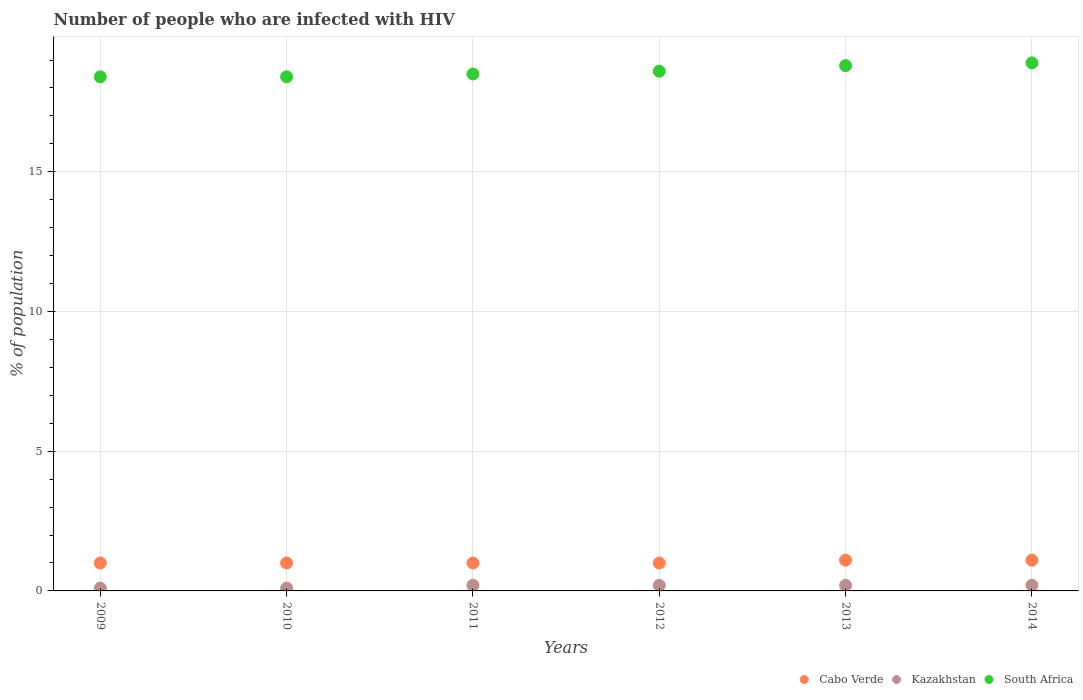How many different coloured dotlines are there?
Your response must be concise. 3. Is the number of dotlines equal to the number of legend labels?
Your response must be concise. Yes. Across all years, what is the maximum percentage of HIV infected population in in Kazakhstan?
Your response must be concise. 0.2. Across all years, what is the minimum percentage of HIV infected population in in South Africa?
Offer a very short reply. 18.4. In which year was the percentage of HIV infected population in in South Africa minimum?
Your response must be concise. 2009. What is the total percentage of HIV infected population in in South Africa in the graph?
Make the answer very short. 111.6. What is the difference between the percentage of HIV infected population in in South Africa in 2010 and that in 2014?
Provide a short and direct response. -0.5. What is the difference between the percentage of HIV infected population in in South Africa in 2013 and the percentage of HIV infected population in in Kazakhstan in 2012?
Provide a short and direct response. 18.6. What is the average percentage of HIV infected population in in South Africa per year?
Your answer should be very brief. 18.6. In the year 2009, what is the difference between the percentage of HIV infected population in in Cabo Verde and percentage of HIV infected population in in South Africa?
Offer a terse response. -17.4. What is the ratio of the percentage of HIV infected population in in South Africa in 2010 to that in 2013?
Provide a short and direct response. 0.98. What is the difference between the highest and the second highest percentage of HIV infected population in in Kazakhstan?
Your response must be concise. 0. What is the difference between the highest and the lowest percentage of HIV infected population in in Cabo Verde?
Make the answer very short. 0.1. In how many years, is the percentage of HIV infected population in in South Africa greater than the average percentage of HIV infected population in in South Africa taken over all years?
Keep it short and to the point. 3. Is the sum of the percentage of HIV infected population in in Kazakhstan in 2009 and 2014 greater than the maximum percentage of HIV infected population in in Cabo Verde across all years?
Offer a terse response. No. Is the percentage of HIV infected population in in South Africa strictly greater than the percentage of HIV infected population in in Kazakhstan over the years?
Provide a short and direct response. Yes. How many dotlines are there?
Offer a very short reply. 3. Are the values on the major ticks of Y-axis written in scientific E-notation?
Provide a short and direct response. No. What is the title of the graph?
Your response must be concise. Number of people who are infected with HIV. Does "Bolivia" appear as one of the legend labels in the graph?
Your answer should be very brief. No. What is the label or title of the Y-axis?
Offer a terse response. % of population. What is the % of population in Kazakhstan in 2009?
Ensure brevity in your answer.  0.1. What is the % of population of South Africa in 2009?
Keep it short and to the point. 18.4. What is the % of population in Cabo Verde in 2010?
Your answer should be compact. 1. What is the % of population in South Africa in 2010?
Ensure brevity in your answer.  18.4. What is the % of population of Cabo Verde in 2011?
Your answer should be compact. 1. What is the % of population in Kazakhstan in 2011?
Offer a very short reply. 0.2. What is the % of population of South Africa in 2011?
Offer a terse response. 18.5. What is the % of population of South Africa in 2012?
Provide a short and direct response. 18.6. What is the % of population of Cabo Verde in 2013?
Provide a succinct answer. 1.1. What is the % of population in South Africa in 2013?
Your response must be concise. 18.8. What is the % of population of South Africa in 2014?
Your answer should be compact. 18.9. Across all years, what is the maximum % of population of Cabo Verde?
Keep it short and to the point. 1.1. Across all years, what is the maximum % of population of Kazakhstan?
Make the answer very short. 0.2. Across all years, what is the minimum % of population of Cabo Verde?
Your response must be concise. 1. Across all years, what is the minimum % of population in Kazakhstan?
Give a very brief answer. 0.1. What is the total % of population of South Africa in the graph?
Your answer should be compact. 111.6. What is the difference between the % of population of Cabo Verde in 2009 and that in 2011?
Ensure brevity in your answer.  0. What is the difference between the % of population in Kazakhstan in 2009 and that in 2012?
Your answer should be compact. -0.1. What is the difference between the % of population in South Africa in 2009 and that in 2012?
Ensure brevity in your answer.  -0.2. What is the difference between the % of population in Kazakhstan in 2009 and that in 2013?
Your answer should be compact. -0.1. What is the difference between the % of population of Cabo Verde in 2009 and that in 2014?
Give a very brief answer. -0.1. What is the difference between the % of population in Kazakhstan in 2009 and that in 2014?
Provide a succinct answer. -0.1. What is the difference between the % of population in Kazakhstan in 2010 and that in 2011?
Your answer should be compact. -0.1. What is the difference between the % of population in South Africa in 2010 and that in 2012?
Provide a short and direct response. -0.2. What is the difference between the % of population of Kazakhstan in 2010 and that in 2013?
Give a very brief answer. -0.1. What is the difference between the % of population in South Africa in 2010 and that in 2013?
Your answer should be very brief. -0.4. What is the difference between the % of population of Cabo Verde in 2010 and that in 2014?
Give a very brief answer. -0.1. What is the difference between the % of population in Kazakhstan in 2010 and that in 2014?
Offer a very short reply. -0.1. What is the difference between the % of population in South Africa in 2010 and that in 2014?
Give a very brief answer. -0.5. What is the difference between the % of population in Cabo Verde in 2011 and that in 2012?
Make the answer very short. 0. What is the difference between the % of population of Kazakhstan in 2011 and that in 2013?
Your response must be concise. 0. What is the difference between the % of population in South Africa in 2011 and that in 2013?
Ensure brevity in your answer.  -0.3. What is the difference between the % of population of Cabo Verde in 2011 and that in 2014?
Offer a very short reply. -0.1. What is the difference between the % of population of Kazakhstan in 2011 and that in 2014?
Make the answer very short. 0. What is the difference between the % of population of South Africa in 2011 and that in 2014?
Your response must be concise. -0.4. What is the difference between the % of population of Kazakhstan in 2012 and that in 2013?
Ensure brevity in your answer.  0. What is the difference between the % of population in South Africa in 2012 and that in 2013?
Offer a terse response. -0.2. What is the difference between the % of population of Cabo Verde in 2012 and that in 2014?
Give a very brief answer. -0.1. What is the difference between the % of population in Kazakhstan in 2012 and that in 2014?
Offer a terse response. 0. What is the difference between the % of population of Kazakhstan in 2013 and that in 2014?
Offer a very short reply. 0. What is the difference between the % of population of South Africa in 2013 and that in 2014?
Your answer should be very brief. -0.1. What is the difference between the % of population in Cabo Verde in 2009 and the % of population in Kazakhstan in 2010?
Your answer should be compact. 0.9. What is the difference between the % of population of Cabo Verde in 2009 and the % of population of South Africa in 2010?
Offer a terse response. -17.4. What is the difference between the % of population of Kazakhstan in 2009 and the % of population of South Africa in 2010?
Give a very brief answer. -18.3. What is the difference between the % of population of Cabo Verde in 2009 and the % of population of Kazakhstan in 2011?
Your response must be concise. 0.8. What is the difference between the % of population in Cabo Verde in 2009 and the % of population in South Africa in 2011?
Your response must be concise. -17.5. What is the difference between the % of population in Kazakhstan in 2009 and the % of population in South Africa in 2011?
Your answer should be compact. -18.4. What is the difference between the % of population in Cabo Verde in 2009 and the % of population in Kazakhstan in 2012?
Your response must be concise. 0.8. What is the difference between the % of population in Cabo Verde in 2009 and the % of population in South Africa in 2012?
Your answer should be very brief. -17.6. What is the difference between the % of population in Kazakhstan in 2009 and the % of population in South Africa in 2012?
Provide a succinct answer. -18.5. What is the difference between the % of population of Cabo Verde in 2009 and the % of population of Kazakhstan in 2013?
Provide a short and direct response. 0.8. What is the difference between the % of population in Cabo Verde in 2009 and the % of population in South Africa in 2013?
Keep it short and to the point. -17.8. What is the difference between the % of population of Kazakhstan in 2009 and the % of population of South Africa in 2013?
Ensure brevity in your answer.  -18.7. What is the difference between the % of population of Cabo Verde in 2009 and the % of population of South Africa in 2014?
Ensure brevity in your answer.  -17.9. What is the difference between the % of population of Kazakhstan in 2009 and the % of population of South Africa in 2014?
Give a very brief answer. -18.8. What is the difference between the % of population of Cabo Verde in 2010 and the % of population of Kazakhstan in 2011?
Your answer should be very brief. 0.8. What is the difference between the % of population in Cabo Verde in 2010 and the % of population in South Africa in 2011?
Offer a terse response. -17.5. What is the difference between the % of population of Kazakhstan in 2010 and the % of population of South Africa in 2011?
Provide a short and direct response. -18.4. What is the difference between the % of population in Cabo Verde in 2010 and the % of population in South Africa in 2012?
Your answer should be very brief. -17.6. What is the difference between the % of population in Kazakhstan in 2010 and the % of population in South Africa in 2012?
Offer a very short reply. -18.5. What is the difference between the % of population of Cabo Verde in 2010 and the % of population of Kazakhstan in 2013?
Make the answer very short. 0.8. What is the difference between the % of population in Cabo Verde in 2010 and the % of population in South Africa in 2013?
Provide a succinct answer. -17.8. What is the difference between the % of population in Kazakhstan in 2010 and the % of population in South Africa in 2013?
Provide a short and direct response. -18.7. What is the difference between the % of population of Cabo Verde in 2010 and the % of population of Kazakhstan in 2014?
Your answer should be compact. 0.8. What is the difference between the % of population in Cabo Verde in 2010 and the % of population in South Africa in 2014?
Provide a succinct answer. -17.9. What is the difference between the % of population of Kazakhstan in 2010 and the % of population of South Africa in 2014?
Make the answer very short. -18.8. What is the difference between the % of population of Cabo Verde in 2011 and the % of population of Kazakhstan in 2012?
Provide a succinct answer. 0.8. What is the difference between the % of population in Cabo Verde in 2011 and the % of population in South Africa in 2012?
Offer a terse response. -17.6. What is the difference between the % of population of Kazakhstan in 2011 and the % of population of South Africa in 2012?
Your answer should be very brief. -18.4. What is the difference between the % of population of Cabo Verde in 2011 and the % of population of Kazakhstan in 2013?
Ensure brevity in your answer.  0.8. What is the difference between the % of population in Cabo Verde in 2011 and the % of population in South Africa in 2013?
Your response must be concise. -17.8. What is the difference between the % of population of Kazakhstan in 2011 and the % of population of South Africa in 2013?
Provide a short and direct response. -18.6. What is the difference between the % of population in Cabo Verde in 2011 and the % of population in South Africa in 2014?
Offer a very short reply. -17.9. What is the difference between the % of population in Kazakhstan in 2011 and the % of population in South Africa in 2014?
Your response must be concise. -18.7. What is the difference between the % of population in Cabo Verde in 2012 and the % of population in Kazakhstan in 2013?
Your answer should be very brief. 0.8. What is the difference between the % of population of Cabo Verde in 2012 and the % of population of South Africa in 2013?
Give a very brief answer. -17.8. What is the difference between the % of population in Kazakhstan in 2012 and the % of population in South Africa in 2013?
Your answer should be very brief. -18.6. What is the difference between the % of population of Cabo Verde in 2012 and the % of population of Kazakhstan in 2014?
Give a very brief answer. 0.8. What is the difference between the % of population in Cabo Verde in 2012 and the % of population in South Africa in 2014?
Ensure brevity in your answer.  -17.9. What is the difference between the % of population in Kazakhstan in 2012 and the % of population in South Africa in 2014?
Provide a short and direct response. -18.7. What is the difference between the % of population in Cabo Verde in 2013 and the % of population in Kazakhstan in 2014?
Your answer should be very brief. 0.9. What is the difference between the % of population of Cabo Verde in 2013 and the % of population of South Africa in 2014?
Ensure brevity in your answer.  -17.8. What is the difference between the % of population of Kazakhstan in 2013 and the % of population of South Africa in 2014?
Provide a short and direct response. -18.7. What is the average % of population in Cabo Verde per year?
Your response must be concise. 1.03. What is the average % of population in Kazakhstan per year?
Your answer should be compact. 0.17. What is the average % of population of South Africa per year?
Provide a short and direct response. 18.6. In the year 2009, what is the difference between the % of population in Cabo Verde and % of population in Kazakhstan?
Give a very brief answer. 0.9. In the year 2009, what is the difference between the % of population of Cabo Verde and % of population of South Africa?
Give a very brief answer. -17.4. In the year 2009, what is the difference between the % of population in Kazakhstan and % of population in South Africa?
Keep it short and to the point. -18.3. In the year 2010, what is the difference between the % of population of Cabo Verde and % of population of Kazakhstan?
Ensure brevity in your answer.  0.9. In the year 2010, what is the difference between the % of population of Cabo Verde and % of population of South Africa?
Provide a short and direct response. -17.4. In the year 2010, what is the difference between the % of population of Kazakhstan and % of population of South Africa?
Ensure brevity in your answer.  -18.3. In the year 2011, what is the difference between the % of population in Cabo Verde and % of population in South Africa?
Ensure brevity in your answer.  -17.5. In the year 2011, what is the difference between the % of population in Kazakhstan and % of population in South Africa?
Your answer should be very brief. -18.3. In the year 2012, what is the difference between the % of population of Cabo Verde and % of population of Kazakhstan?
Give a very brief answer. 0.8. In the year 2012, what is the difference between the % of population in Cabo Verde and % of population in South Africa?
Make the answer very short. -17.6. In the year 2012, what is the difference between the % of population in Kazakhstan and % of population in South Africa?
Provide a succinct answer. -18.4. In the year 2013, what is the difference between the % of population in Cabo Verde and % of population in South Africa?
Ensure brevity in your answer.  -17.7. In the year 2013, what is the difference between the % of population in Kazakhstan and % of population in South Africa?
Provide a succinct answer. -18.6. In the year 2014, what is the difference between the % of population in Cabo Verde and % of population in Kazakhstan?
Provide a short and direct response. 0.9. In the year 2014, what is the difference between the % of population in Cabo Verde and % of population in South Africa?
Keep it short and to the point. -17.8. In the year 2014, what is the difference between the % of population in Kazakhstan and % of population in South Africa?
Your answer should be compact. -18.7. What is the ratio of the % of population of South Africa in 2009 to that in 2010?
Your answer should be very brief. 1. What is the ratio of the % of population of Cabo Verde in 2009 to that in 2012?
Offer a very short reply. 1. What is the ratio of the % of population in Kazakhstan in 2009 to that in 2012?
Make the answer very short. 0.5. What is the ratio of the % of population in South Africa in 2009 to that in 2012?
Keep it short and to the point. 0.99. What is the ratio of the % of population in South Africa in 2009 to that in 2013?
Make the answer very short. 0.98. What is the ratio of the % of population of South Africa in 2009 to that in 2014?
Provide a succinct answer. 0.97. What is the ratio of the % of population in Cabo Verde in 2010 to that in 2011?
Your answer should be very brief. 1. What is the ratio of the % of population in South Africa in 2010 to that in 2011?
Provide a succinct answer. 0.99. What is the ratio of the % of population of Cabo Verde in 2010 to that in 2012?
Provide a succinct answer. 1. What is the ratio of the % of population of Kazakhstan in 2010 to that in 2012?
Your answer should be compact. 0.5. What is the ratio of the % of population of Cabo Verde in 2010 to that in 2013?
Offer a terse response. 0.91. What is the ratio of the % of population of Kazakhstan in 2010 to that in 2013?
Provide a succinct answer. 0.5. What is the ratio of the % of population of South Africa in 2010 to that in 2013?
Make the answer very short. 0.98. What is the ratio of the % of population of Cabo Verde in 2010 to that in 2014?
Make the answer very short. 0.91. What is the ratio of the % of population of South Africa in 2010 to that in 2014?
Offer a very short reply. 0.97. What is the ratio of the % of population in Cabo Verde in 2011 to that in 2013?
Make the answer very short. 0.91. What is the ratio of the % of population in Kazakhstan in 2011 to that in 2013?
Your answer should be very brief. 1. What is the ratio of the % of population in Cabo Verde in 2011 to that in 2014?
Give a very brief answer. 0.91. What is the ratio of the % of population in Kazakhstan in 2011 to that in 2014?
Your answer should be very brief. 1. What is the ratio of the % of population in South Africa in 2011 to that in 2014?
Provide a short and direct response. 0.98. What is the ratio of the % of population of Cabo Verde in 2012 to that in 2013?
Offer a very short reply. 0.91. What is the ratio of the % of population of Kazakhstan in 2012 to that in 2013?
Give a very brief answer. 1. What is the ratio of the % of population in South Africa in 2012 to that in 2013?
Provide a succinct answer. 0.99. What is the ratio of the % of population of Cabo Verde in 2012 to that in 2014?
Keep it short and to the point. 0.91. What is the ratio of the % of population in Kazakhstan in 2012 to that in 2014?
Ensure brevity in your answer.  1. What is the ratio of the % of population of South Africa in 2012 to that in 2014?
Your answer should be very brief. 0.98. What is the ratio of the % of population of Cabo Verde in 2013 to that in 2014?
Your answer should be very brief. 1. What is the difference between the highest and the second highest % of population in Cabo Verde?
Ensure brevity in your answer.  0. What is the difference between the highest and the second highest % of population in Kazakhstan?
Your response must be concise. 0. What is the difference between the highest and the lowest % of population in Cabo Verde?
Ensure brevity in your answer.  0.1. What is the difference between the highest and the lowest % of population of Kazakhstan?
Keep it short and to the point. 0.1. What is the difference between the highest and the lowest % of population of South Africa?
Keep it short and to the point. 0.5. 